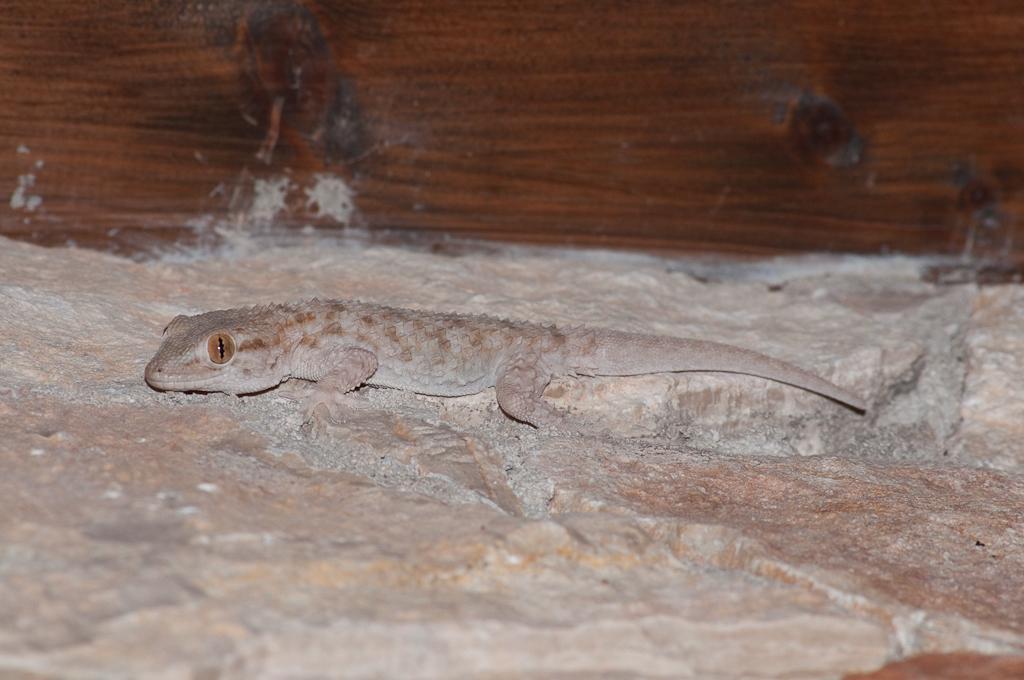Please provide a concise description of this image. This picture contains a lizard. It is on the rock. In the background, we see a wall in brown color. 